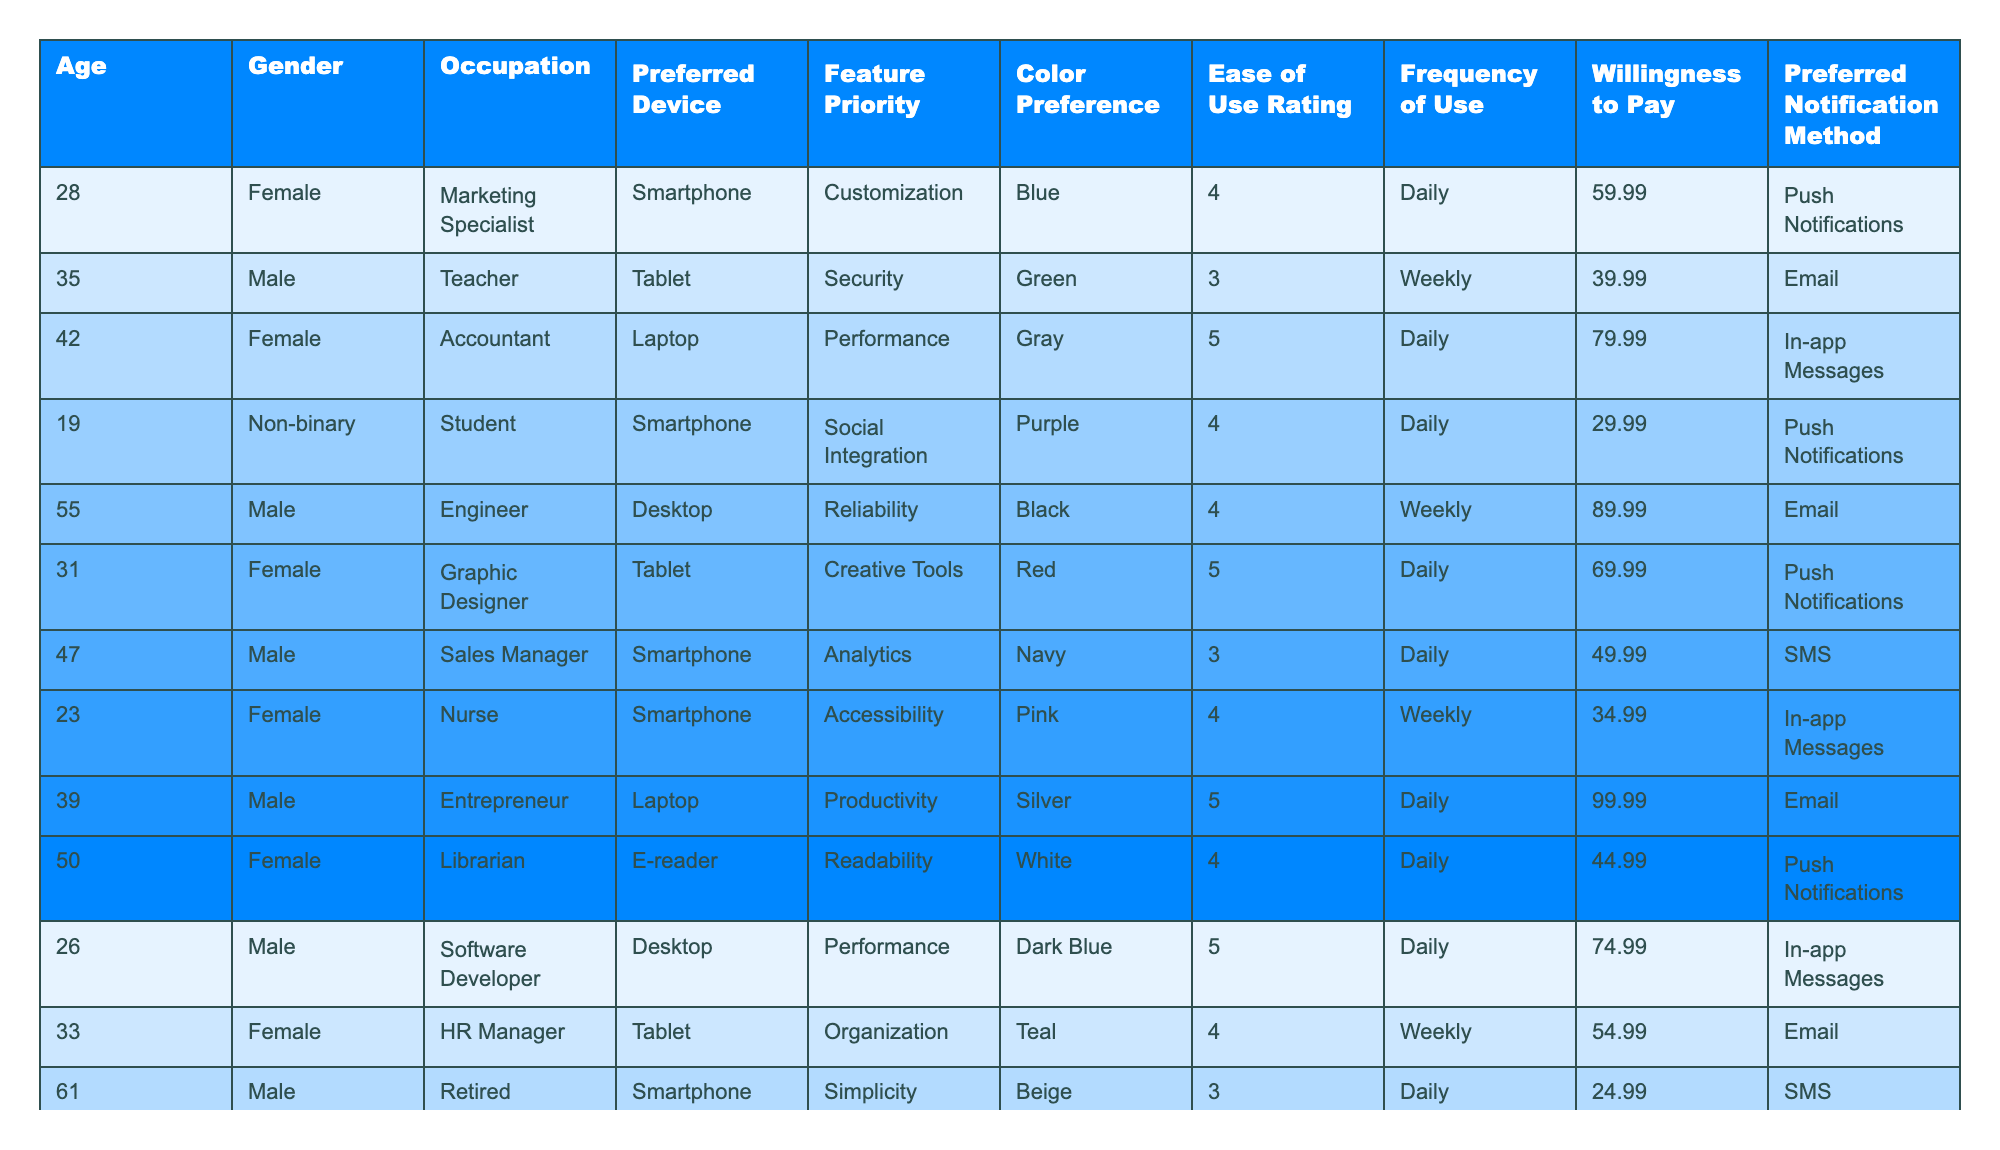What is the preferred device for the majority of respondents? By reviewing the "Preferred Device" column, the most frequently mentioned devices are Smartphone, Tablet, and Laptop. Counting the instances, Smartphone appears 6 times, Tablet 4 times, and Laptop 3 times. Since Smartphone has the highest occurrence, it is the preferred device for the majority.
Answer: Smartphone What is the average Ease of Use Rating across all respondents? To find the average, sum up the Ease of Use Ratings (4 + 3 + 5 + 4 + 4 + 5 + 3 + 4 + 4 + 4 + 3 + 4 + 5) which gives 51, and divide by the total number of respondents (13). Thus, the average is 51/13 ≈ 3.92.
Answer: 3.92 Is there a respondent with a willingness to pay of $99.99? Looking at the "Willingness to Pay" column, $99.99 appears once for the respondent who is an Entrepreneur. Therefore, the statement is true.
Answer: Yes What percentage of respondents rated Ease of Use as a 5? From the "Ease of Use Rating" column, 5 appears 5 times out of 13 total responses. To calculate the percentage, (5/13) * 100 ≈ 38.46%.
Answer: Approximately 38.46% Which gender has the highest representation among respondents? By counting the occurrences of each gender in the "Gender" column, Female appears 6 times, Male appears 5 times, and Non-binary appears 2 times. Therefore, Female has the highest representation.
Answer: Female What is the color preference of the respondent who is a Marketing Specialist? Referencing the "Color Preference" column, the Marketing Specialist has a color preference listed as Blue.
Answer: Blue How many respondents prefer Push Notifications as their notification method? Counting the "Preferred Notification Method" column, Push Notifications are selected by 5 respondents out of 13.
Answer: 5 What is the maximum willingness to pay among the respondents? Examining the "Willingness to Pay" column, the highest value is $99.99 for the Entrepreneur.
Answer: $99.99 Do any non-binary respondents prefer a Laptop as their device? Check the "Preferred Device" column for the non-binary respondent, who prefers a Smartphone. Therefore, the answer is no.
Answer: No What feature has the highest priority overall? Evaluating the "Feature Priority" column, Performance appears 3 times, Customization and Accessibility each appear 2 times, while other features appear less frequently. Hence, Performance is the highly prioritized feature.
Answer: Performance 